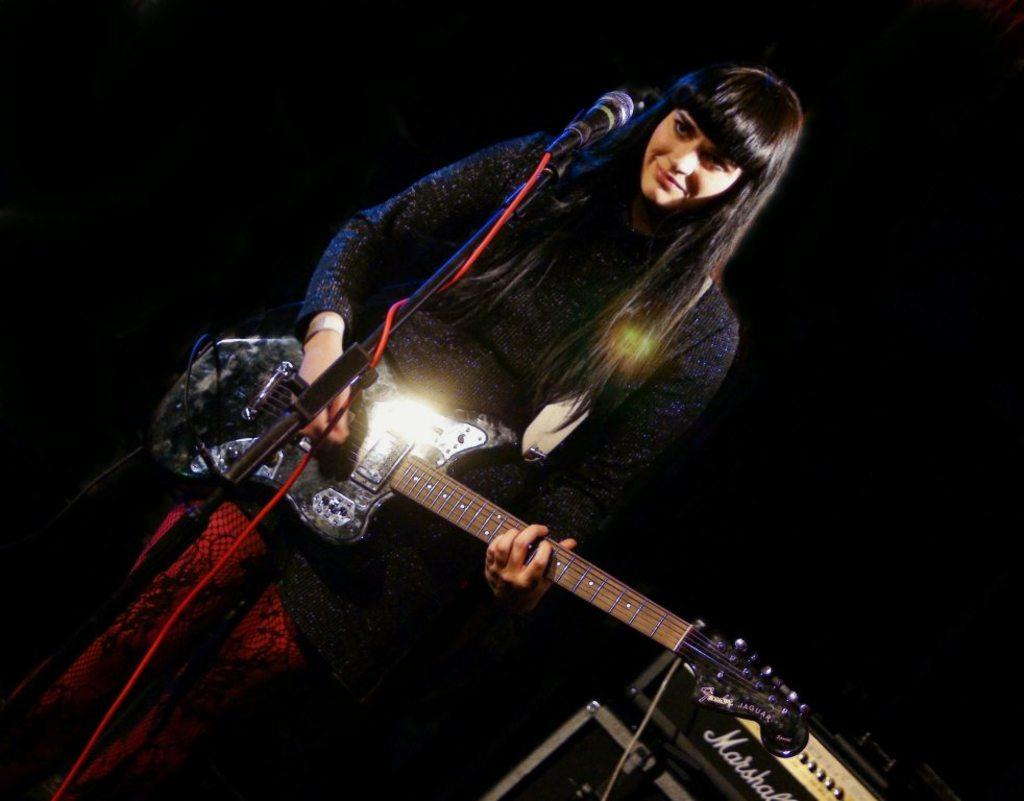Who is the main subject in the image? There is a woman in the image. What is the woman doing in the image? The woman is playing a guitar. What object is in front of the woman? There is a microphone in front of the woman. How many caps can be seen on the woman's arms in the image? There are no caps visible on the woman's arms in the image. 